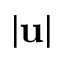Convert formula to latex. <formula><loc_0><loc_0><loc_500><loc_500>| u |</formula> 